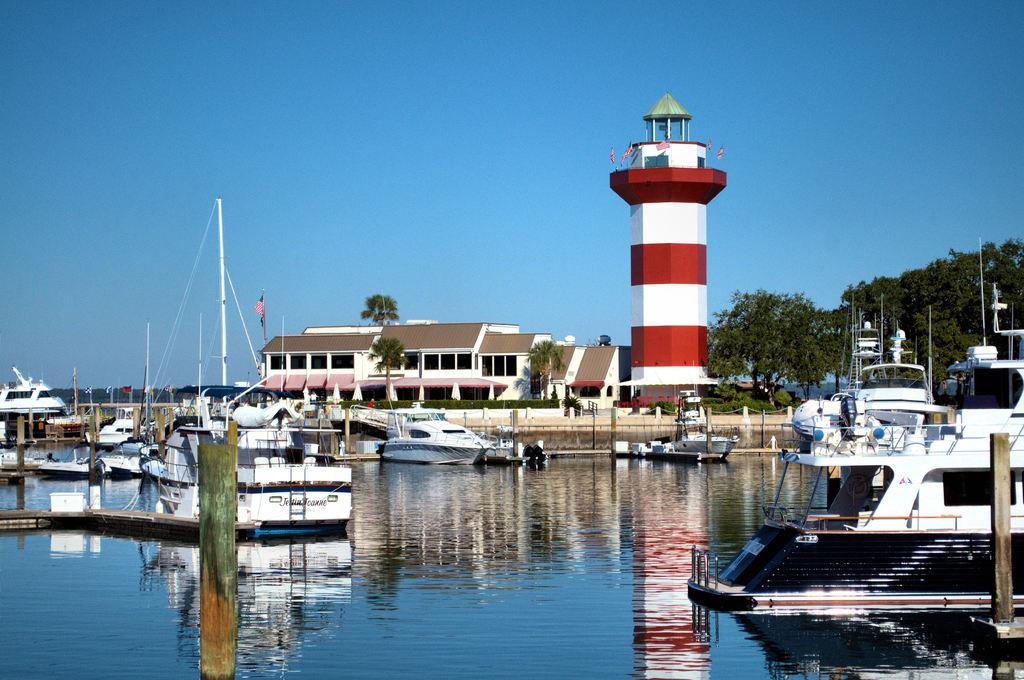What is the main subject of the image? The main subject of the image is water. What else can be seen in the water? There are ships in the image. What can be seen in the background of the image? There are houses, trees, and the sky visible in the background of the image. Can you see a field of crops near the seashore in the image? There is no field of crops or seashore present in the image; it features water with ships and a background with houses, trees, and the sky. 